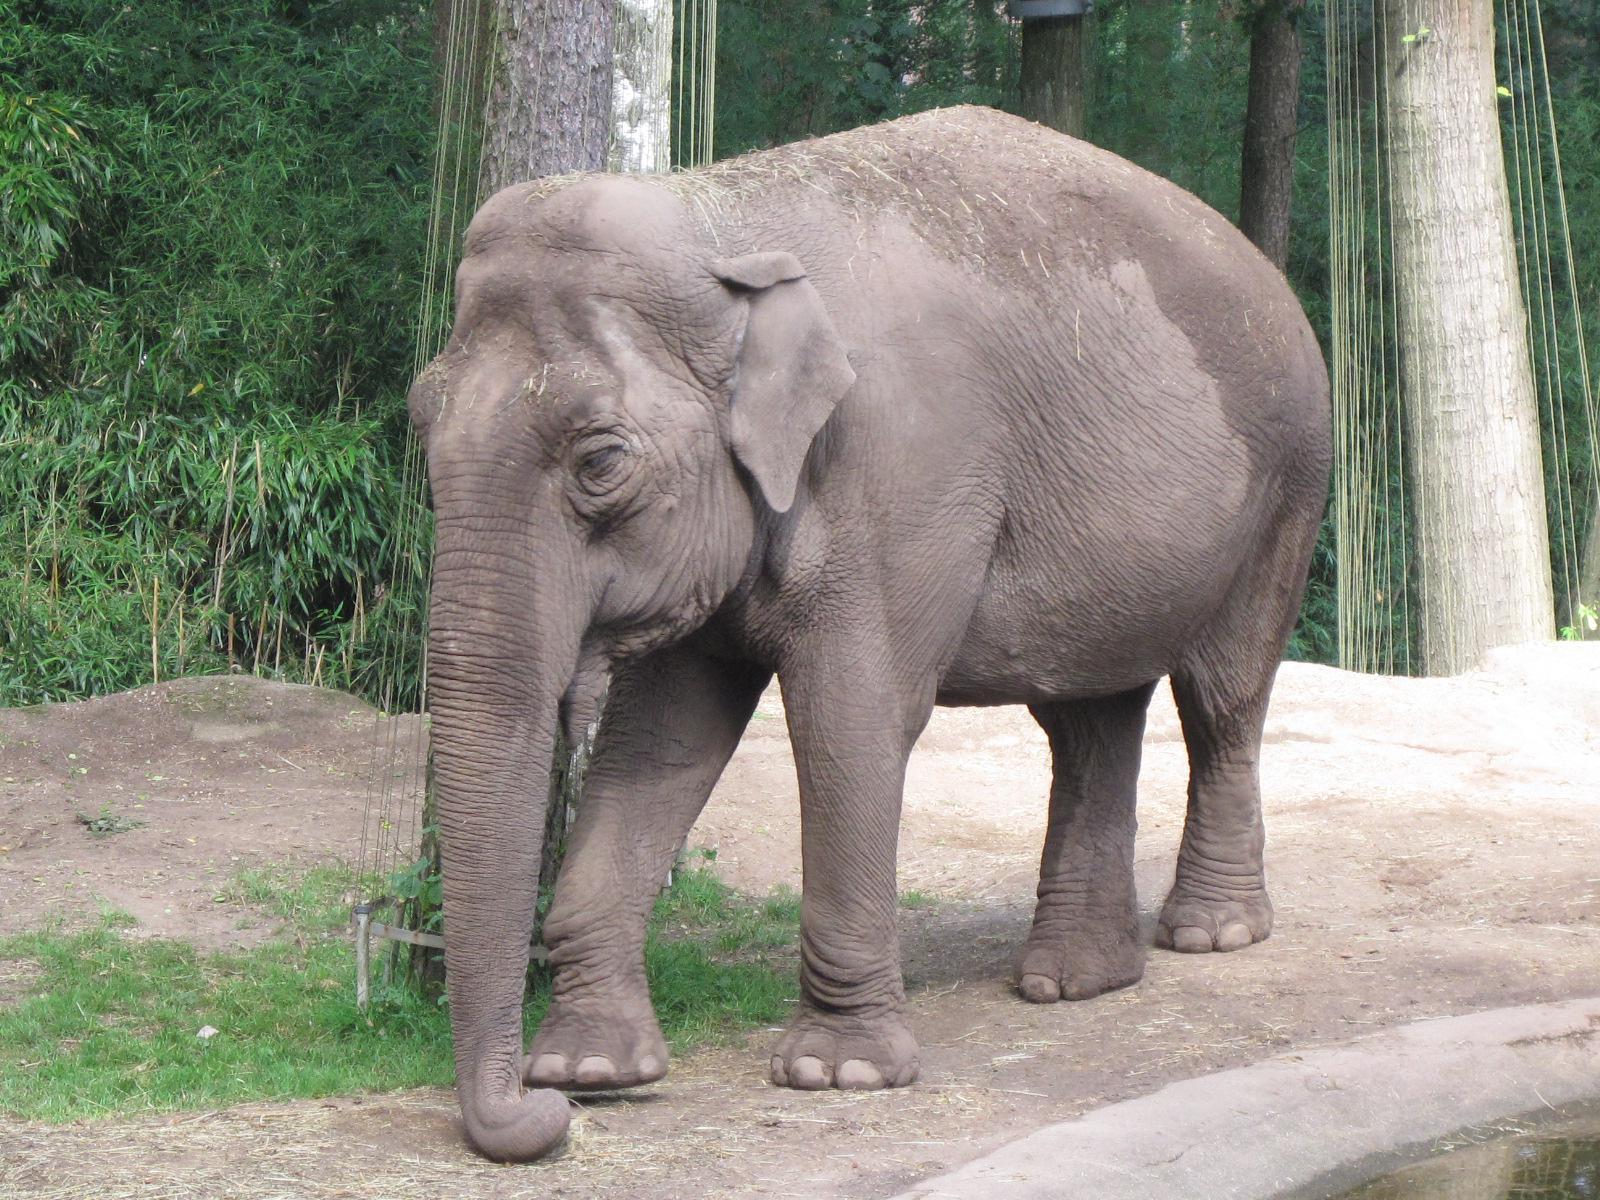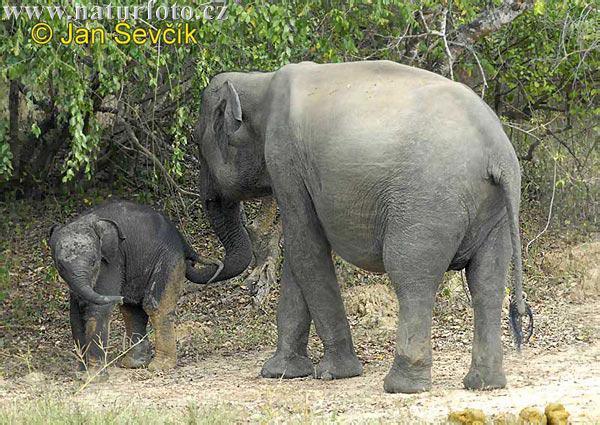The first image is the image on the left, the second image is the image on the right. For the images shown, is this caption "One image shows only an adult elephant interacting with a young elephant while the other image shows a single elephant." true? Answer yes or no. Yes. The first image is the image on the left, the second image is the image on the right. Evaluate the accuracy of this statement regarding the images: "An image shows one baby elephant standing by one adult elephant on dry land.". Is it true? Answer yes or no. Yes. 